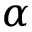Convert formula to latex. <formula><loc_0><loc_0><loc_500><loc_500>\alpha</formula> 